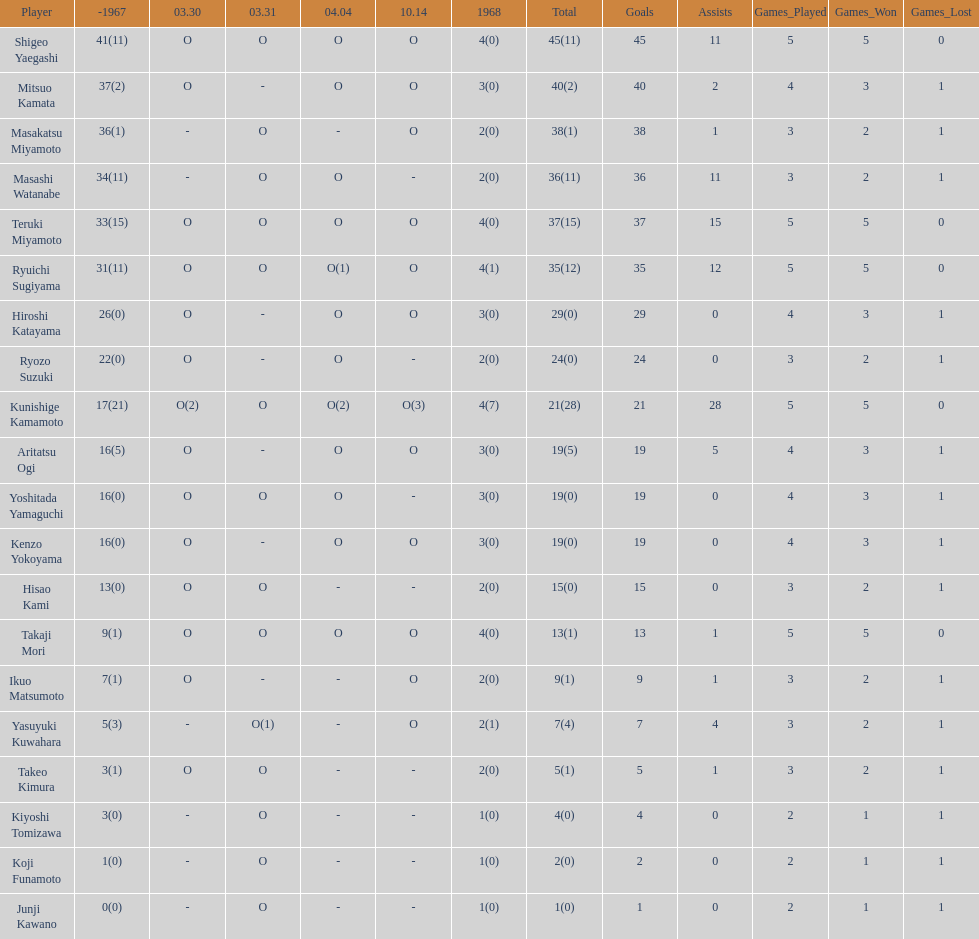How many players made an appearance that year? 20. 